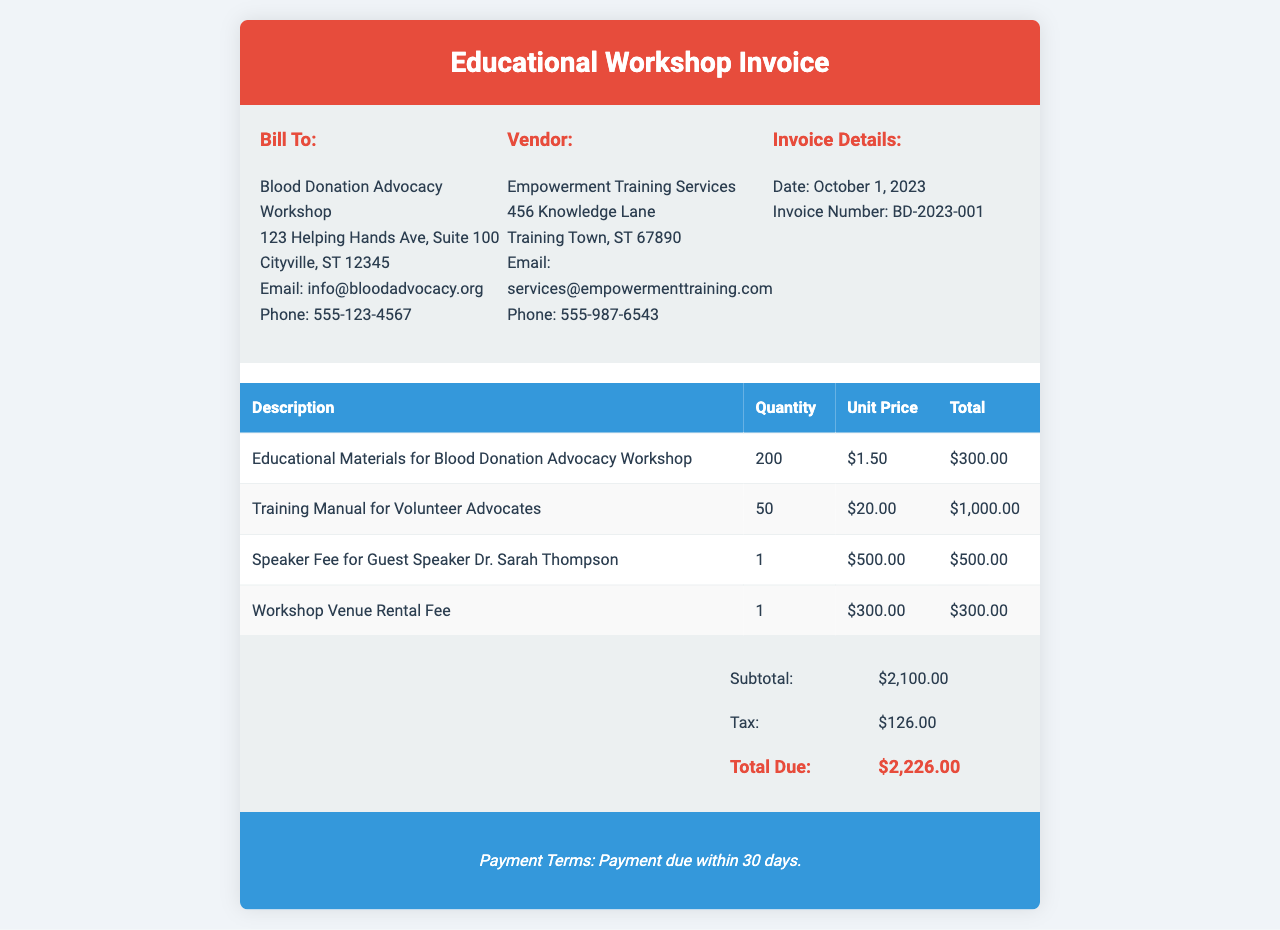What is the invoice number? The invoice number is listed in the Invoice Details section as BD-2023-001.
Answer: BD-2023-001 What is the total due amount? The total due amount is provided at the end of the invoice, which includes the subtotal and tax.
Answer: $2,226.00 Who is the speaker for the workshop? The speaker's name can be found in the services table, specifically under the Speaker Fee entry.
Answer: Dr. Sarah Thompson What is the tax amount charged? The tax amount is mentioned in the total section of the invoice as Tax.
Answer: $126.00 How many training manuals were ordered? The quantity of training manuals is listed in the services table for the Training Manual for Volunteer Advocates.
Answer: 50 What is the subtotal before tax? The subtotal is listed in the total section of the invoice, calculated from all services provided.
Answer: $2,100.00 What is the address of the vendor? The vendor's address can be found under the Vendor section of the invoice.
Answer: 456 Knowledge Lane When is the payment due? The payment terms state the time frame within which the payment should be made.
Answer: 30 days What is the unit price for educational materials? The unit price for the educational materials is noted in the services table for the first entry.
Answer: $1.50 